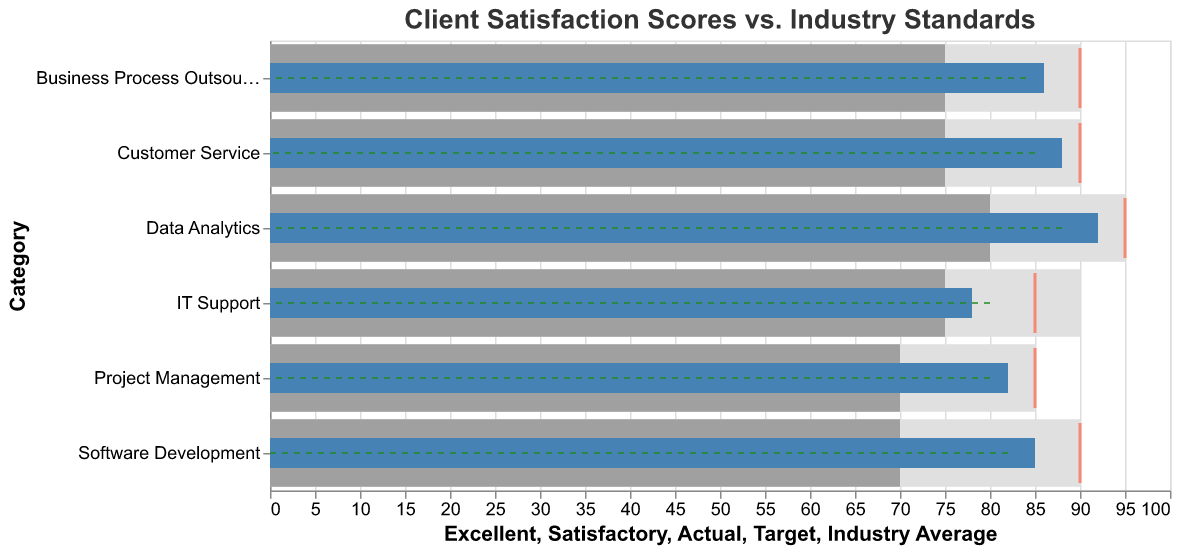what is the title of the chart? The text at the top of the chart typically indicates the title. Here, it reads, "Client Satisfaction Scores vs. Industry Standards."
Answer: Client Satisfaction Scores vs. Industry Standards What service category has the highest actual client satisfaction score? By looking at the 'Actual' bars, the one furthest to the right will indicate the highest score. Here, the category Data Analytics has an Actual score of 92.
Answer: Data Analytics Which category has an actual score below the industry average? Compare the 'Actual' bars with the 'Industry Average' markers for each category. The Software Development, IT Support, and Project Management categories have actual scores below their industry averages (85 < 88, 78 < 80, 82 < 85, respectively).
Answer: Software Development, IT Support, and Project Management What is the difference between the actual and target scores for Customer Service? Look at the 'Actual' and 'Target' markers for Customer Service. The actual score is 88, and the target score is 90. The difference is calculated as 90 - 88.
Answer: 2 How does the IT Support actual score compare to its satisfactory threshold? Observe the 'Actual' bar in IT Support and compare it to the 'Satisfactory' range. The actual score is 78, which falls slightly above the satisfactory threshold of 75.
Answer: Above Which category is the closest to meeting its target score? Compare the 'Actual' tick marks to the 'Target' tick marks across categories. Customer Service (88 vs. 90) and Project Management (82 vs. 85) are both 3 units away from their targets.
Answer: Customer Service and Project Management What is the range of the 'Excellent' threshold for the Data Analytics category? Look at the 'Excellent' bar for Data Analytics. The 'Excellent' value for Data Analytics is at 95.
Answer: 95 How many categories have actual scores exceeding the industry average? Compare the 'Actual' bars and 'Industry Average' markers across categories. Data Analytics (92 vs. 88), Customer Service (88 vs. 85), and Business Process Outsourcing (86 vs. 84) have actual scores exceeding the industry averages.
Answer: 3 